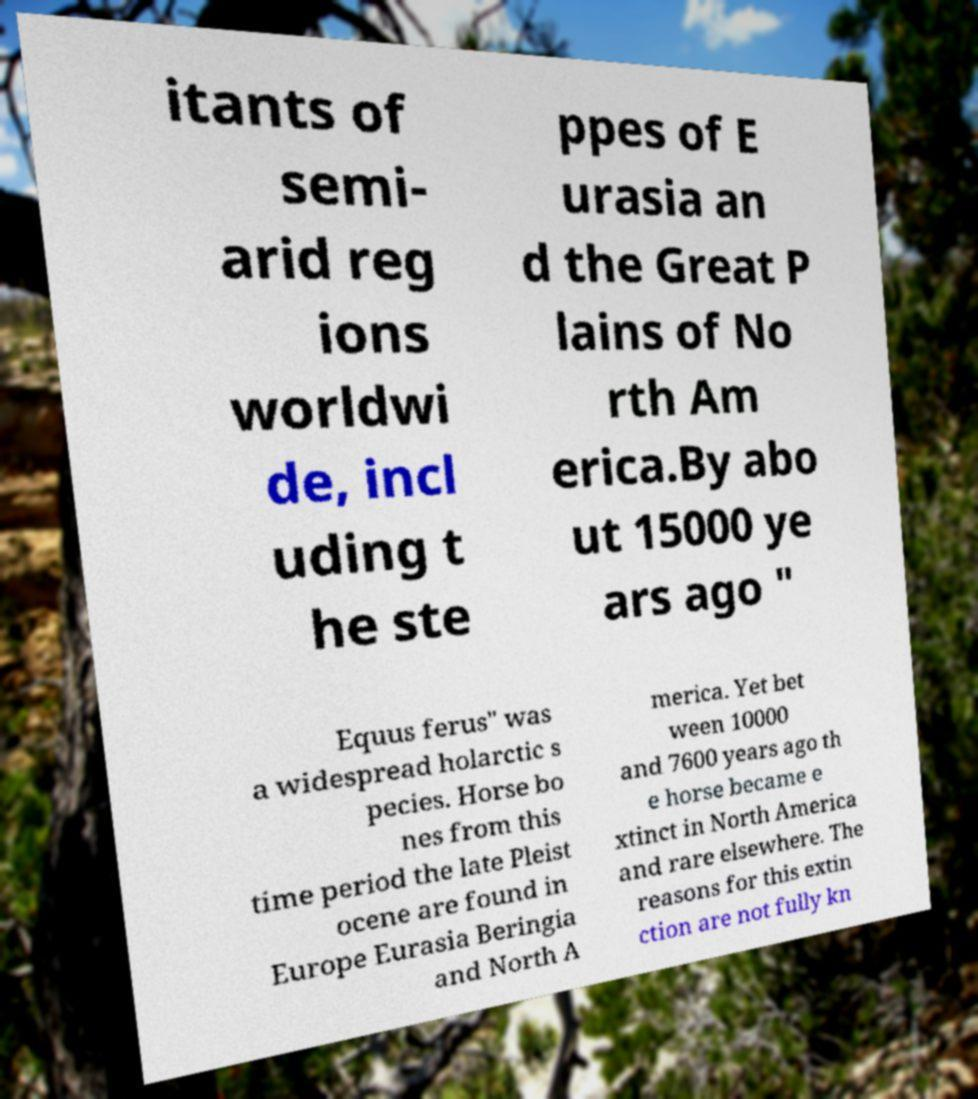Could you extract and type out the text from this image? itants of semi- arid reg ions worldwi de, incl uding t he ste ppes of E urasia an d the Great P lains of No rth Am erica.By abo ut 15000 ye ars ago " Equus ferus" was a widespread holarctic s pecies. Horse bo nes from this time period the late Pleist ocene are found in Europe Eurasia Beringia and North A merica. Yet bet ween 10000 and 7600 years ago th e horse became e xtinct in North America and rare elsewhere. The reasons for this extin ction are not fully kn 